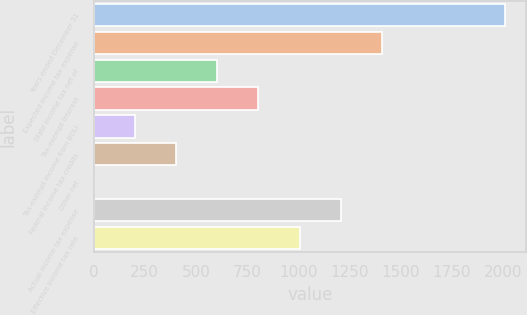Convert chart. <chart><loc_0><loc_0><loc_500><loc_500><bar_chart><fcel>Years ended December 31<fcel>Expected income tax expense<fcel>State income tax net of<fcel>Tax-exempt interest<fcel>Tax-exempt income from BOLI<fcel>Federal income tax credits<fcel>Other net<fcel>Actual income tax expense<fcel>Effective income tax rate<nl><fcel>2012<fcel>1408.94<fcel>604.86<fcel>805.88<fcel>202.82<fcel>403.84<fcel>1.8<fcel>1207.92<fcel>1006.9<nl></chart> 